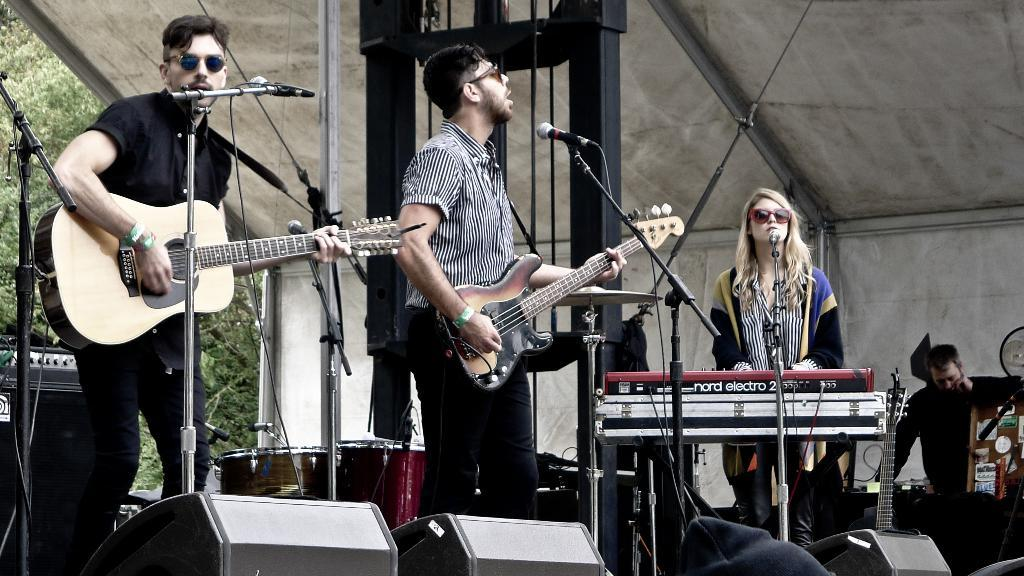Who is present in the image? There are people in the image. Where are the people located? The people are on a stage. What are the people doing on the stage? The people are playing musical instruments. What type of texture can be seen on the ladybug in the image? There is no ladybug present in the image. How many cribs are visible on the stage in the image? There are no cribs present in the image; the people are playing musical instruments on a stage. 